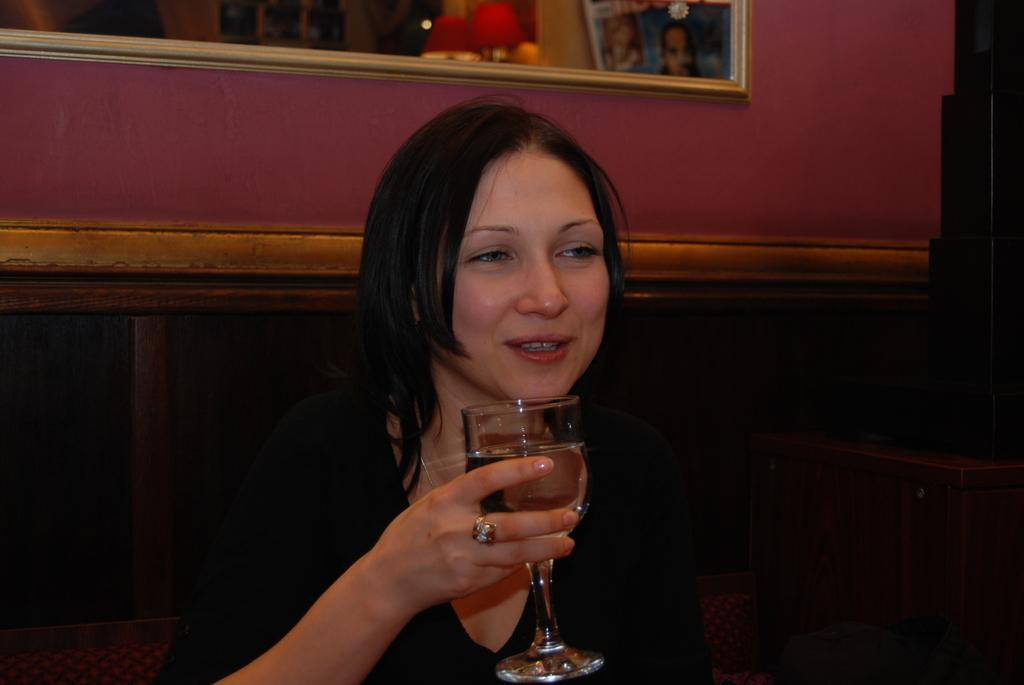What is the main subject of the image? There is a person in the image. What is the person wearing? The person is wearing a black dress. What is the person holding in her hand? The person is holding a glass in her hand. What can be seen on the wall in the background? There is a photo frame on the wall in the background. Are there any dinosaurs visible in the image? No, there are no dinosaurs present in the image. 